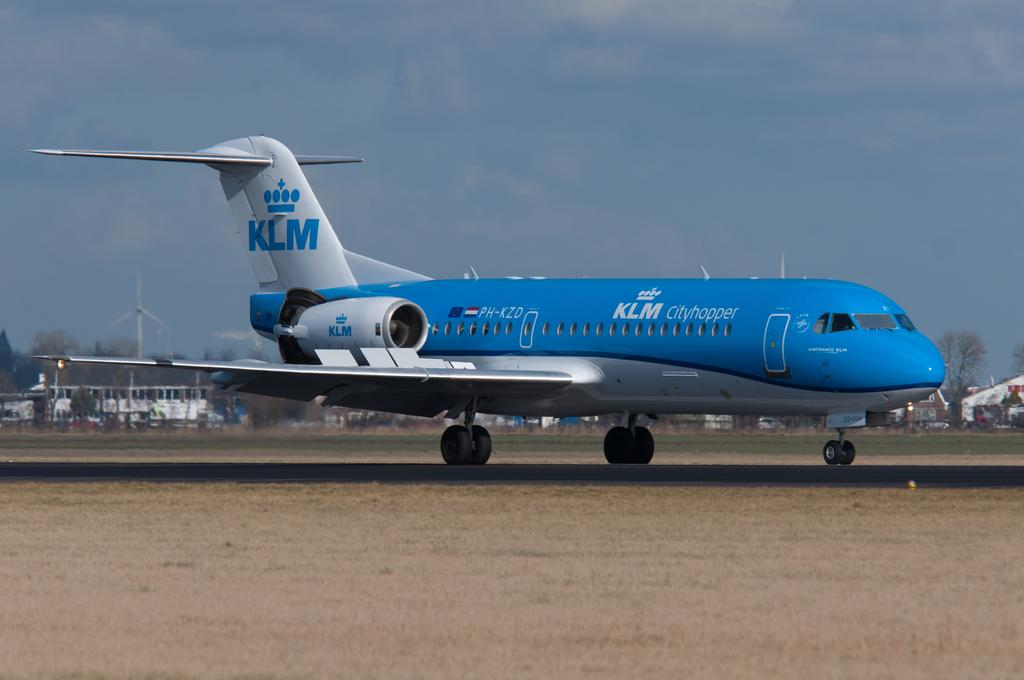<image>
Give a short and clear explanation of the subsequent image. An airplane with the letters KLM written on the tail 